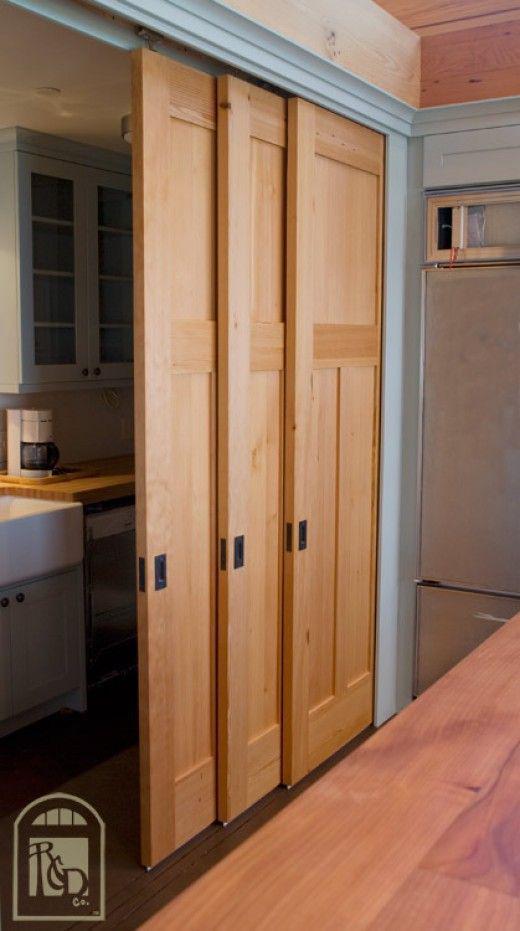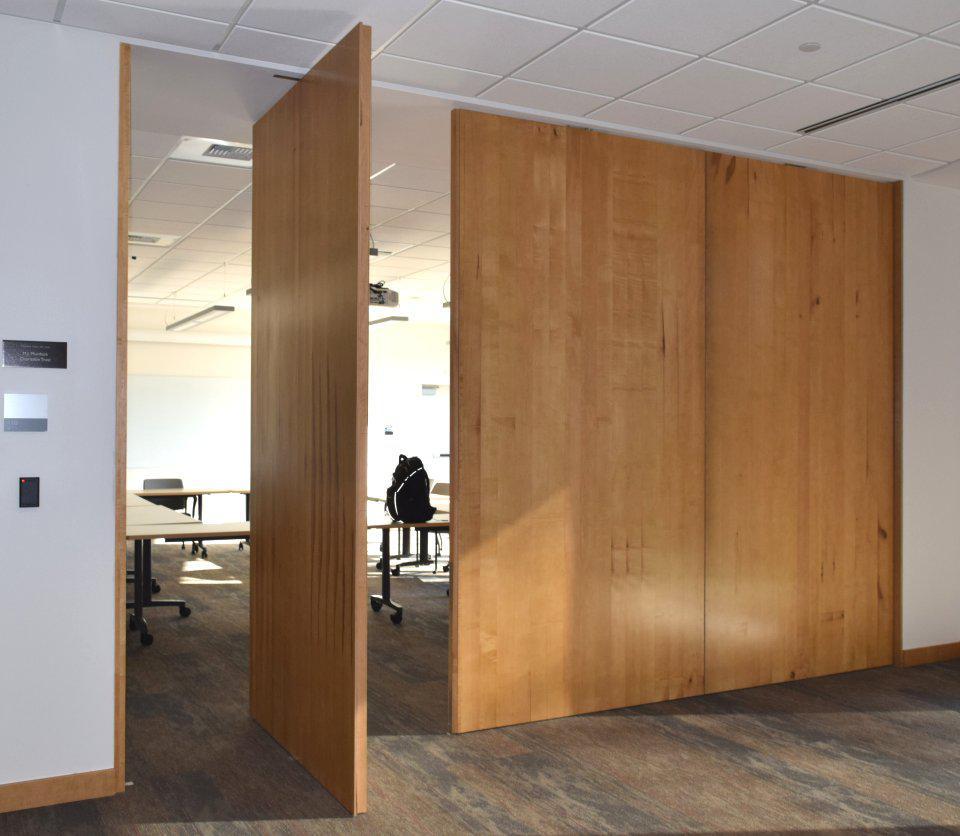The first image is the image on the left, the second image is the image on the right. For the images shown, is this caption "An image shows triple wooden sliding doors topped with molding trim." true? Answer yes or no. Yes. The first image is the image on the left, the second image is the image on the right. Assess this claim about the two images: "The door in the image or the right is made of natural colored wood panels.". Correct or not? Answer yes or no. Yes. The first image is the image on the left, the second image is the image on the right. For the images displayed, is the sentence "In one image, a tan wood three-panel door has square inlays at the top and two long rectangles at the bottom." factually correct? Answer yes or no. Yes. The first image is the image on the left, the second image is the image on the right. Evaluate the accuracy of this statement regarding the images: "Two sets of closed closet doors have the same number of panels, but one set is wider than the other.". Is it true? Answer yes or no. No. 